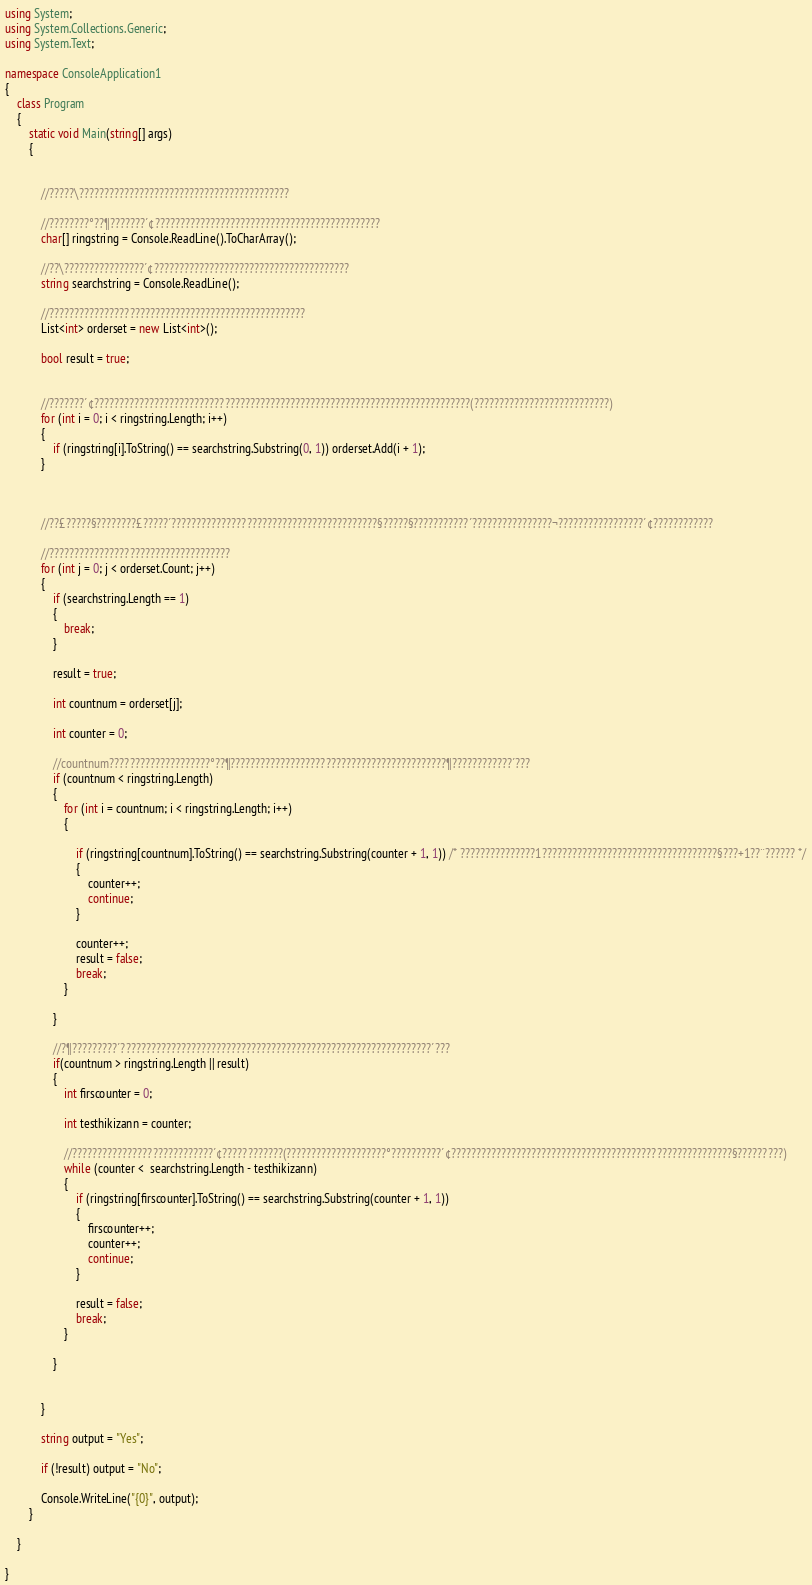Convert code to text. <code><loc_0><loc_0><loc_500><loc_500><_C#_>using System;
using System.Collections.Generic;
using System.Text;

namespace ConsoleApplication1
{
    class Program
    {
        static void Main(string[] args)
        {


            //?????\??????????????????????????????????????????

            //????????°??¶???????´¢?????????????????????????????????????????????
            char[] ringstring = Console.ReadLine().ToCharArray();

            //??\????????????????´¢???????????????????????????????????????
            string searchstring = Console.ReadLine();

            //???????????????????????????????????????????????????
            List<int> orderset = new List<int>();

            bool result = true;


            //???????´¢???????????????????????????????????????????????????????????????????????????(???????????????????????????)
            for (int i = 0; i < ringstring.Length; i++)
            {
                if (ringstring[i].ToString() == searchstring.Substring(0, 1)) orderset.Add(i + 1);
            }



            //??£?????§????????£?????´?????????????????????????????????????????§?????§???????????´????????????????¬?????????????????´¢????????????

            //????????????????????????????????????
            for (int j = 0; j < orderset.Count; j++)
            {
                if (searchstring.Length == 1)
                {
                    break;
                }

                result = true;

                int countnum = orderset[j];

                int counter = 0;

                //countnum????????????????????°??¶???????????????????????????????????????????¶????????????´??? 
                if (countnum < ringstring.Length)
                {
                    for (int i = countnum; i < ringstring.Length; i++)
                    {

                        if (ringstring[countnum].ToString() == searchstring.Substring(counter + 1, 1)) /* ???????????????1???????????????????????????????????§???+1??¨?????? */
                        {
                            counter++;
                            continue;
                        }

                        counter++;
                        result = false;
                        break;
                    }

                }

                //?¶?????????´??????????????????????????????????????????????????????????????´???
                if(countnum > ringstring.Length || result)
                {
                    int firscounter = 0;

                    int testhikizann = counter;

                    //????????????????????????????´¢????????????(????????????????????°??????????´¢????????????????????????????????????????????????????????§?????????)
                    while (counter <  searchstring.Length - testhikizann)
                    {
                        if (ringstring[firscounter].ToString() == searchstring.Substring(counter + 1, 1))
                        {
                            firscounter++;
                            counter++;
                            continue;
                        }

                        result = false;
                        break;
                    }

                }

     
            }

            string output = "Yes";

            if (!result) output = "No";

            Console.WriteLine("{0}", output);
        }
    
    }

}</code> 